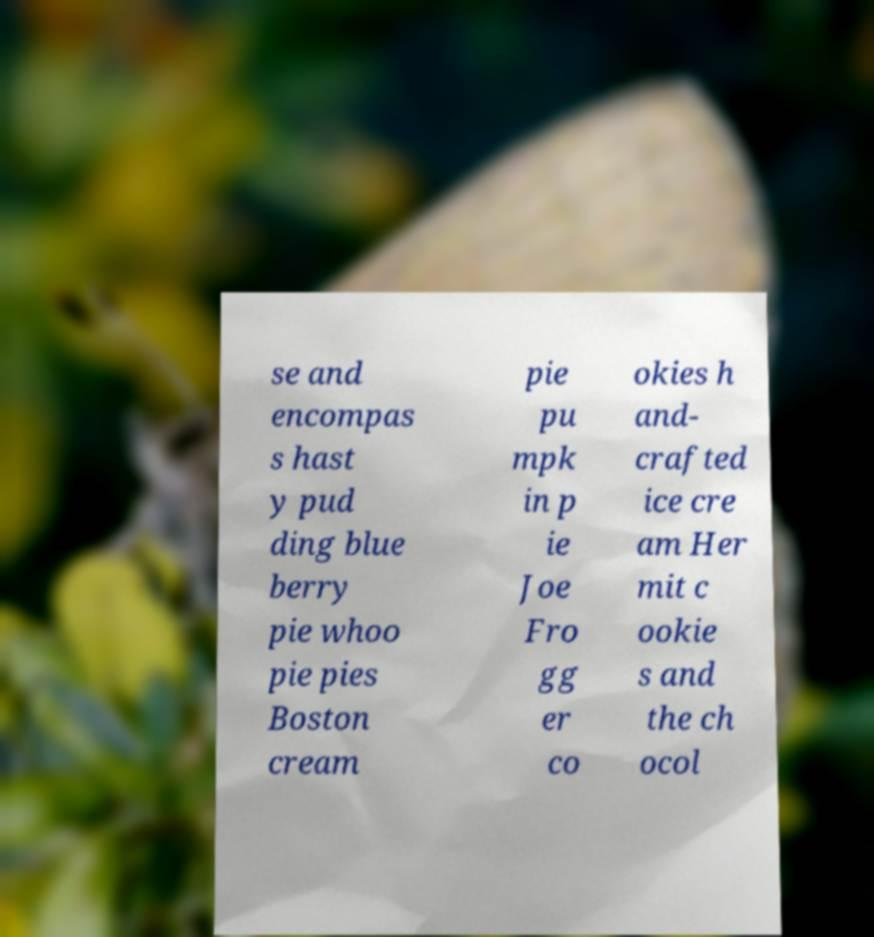Can you accurately transcribe the text from the provided image for me? se and encompas s hast y pud ding blue berry pie whoo pie pies Boston cream pie pu mpk in p ie Joe Fro gg er co okies h and- crafted ice cre am Her mit c ookie s and the ch ocol 